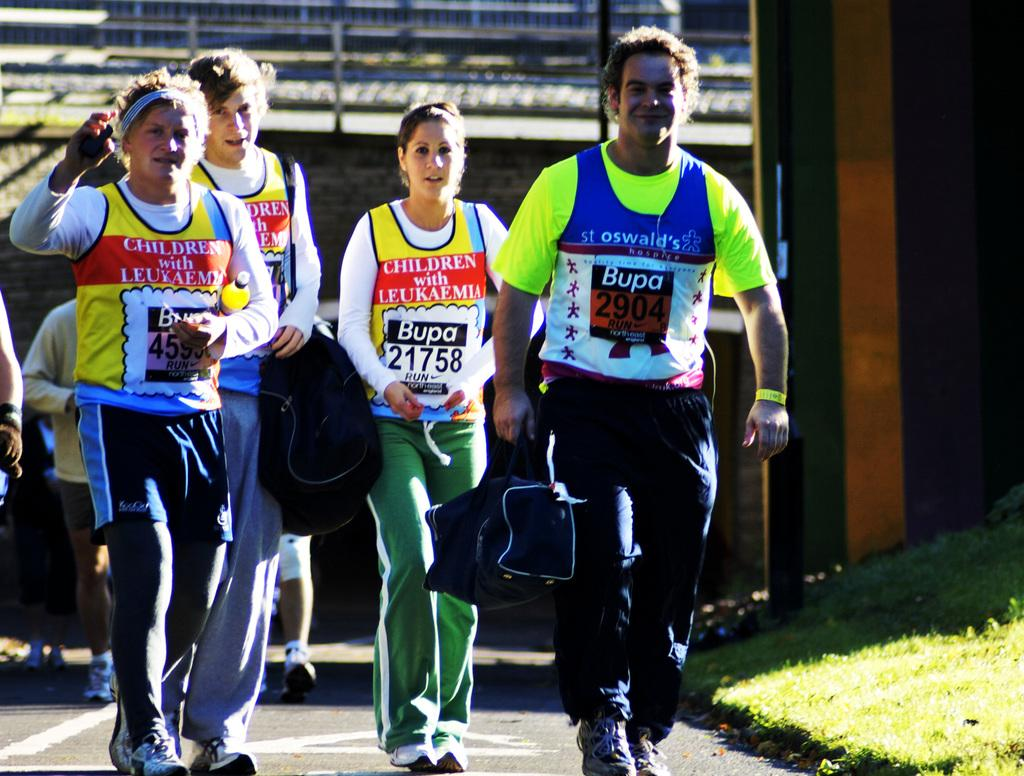Provide a one-sentence caption for the provided image. Four people are walking down a road wearing Bupa racing bibs. 